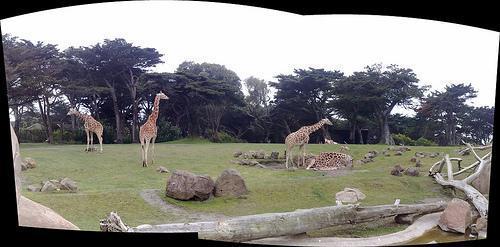How many giraffe are there?
Give a very brief answer. 3. 